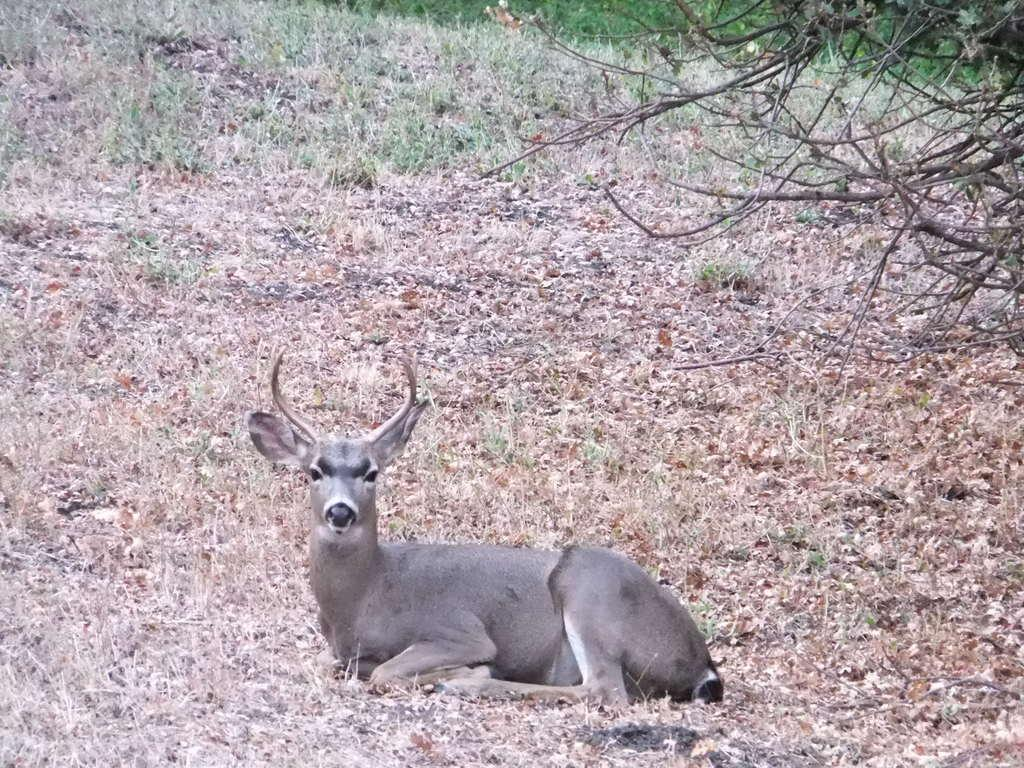What is the main subject of the image? There is an animal sitting on the ground in the image. What type of terrain is visible in the background of the image? There is grass on the ground and dry trees in the background of the image. Can you see a gun in the image? No, there is no gun present in the image. Is the animal stuck in quicksand in the image? No, there is no quicksand present in the image. 